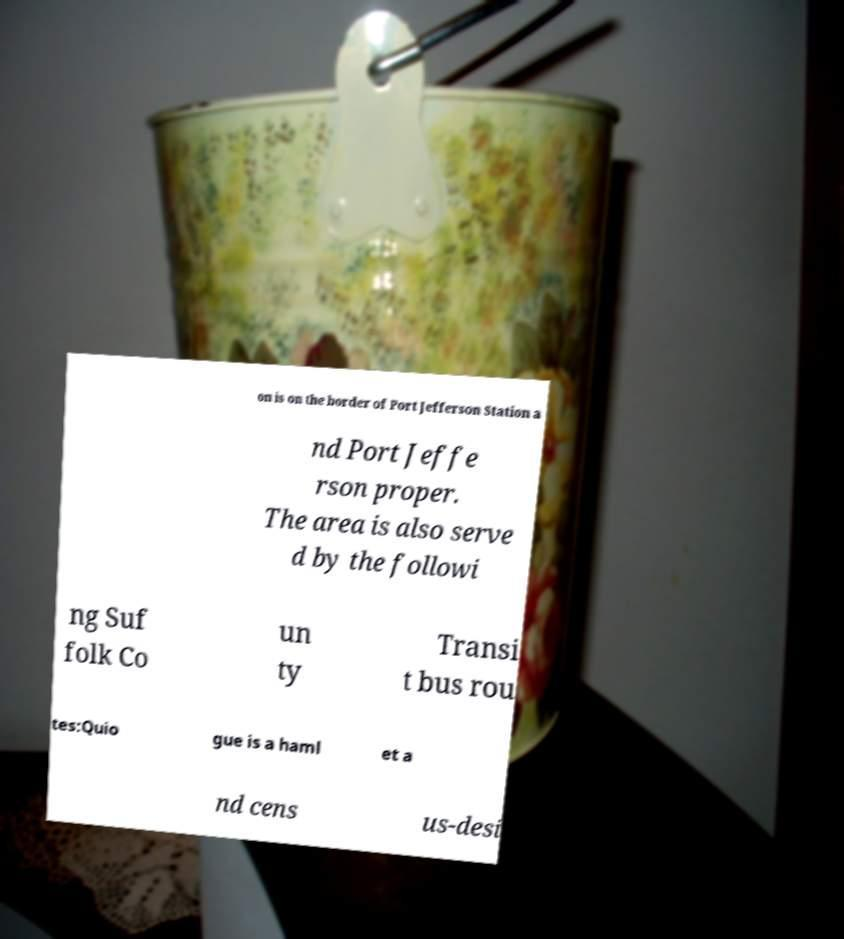I need the written content from this picture converted into text. Can you do that? on is on the border of Port Jefferson Station a nd Port Jeffe rson proper. The area is also serve d by the followi ng Suf folk Co un ty Transi t bus rou tes:Quio gue is a haml et a nd cens us-desi 